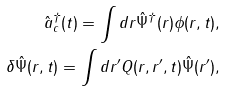<formula> <loc_0><loc_0><loc_500><loc_500>\hat { a } _ { c } ^ { \dagger } ( t ) = \int d r \hat { \Psi } ^ { \dagger } ( r ) \phi ( r , t ) , \\ \delta \hat { \Psi } ( r , t ) = \int d r ^ { \prime } Q ( r , r ^ { \prime } , t ) \hat { \Psi } ( r ^ { \prime } ) ,</formula> 